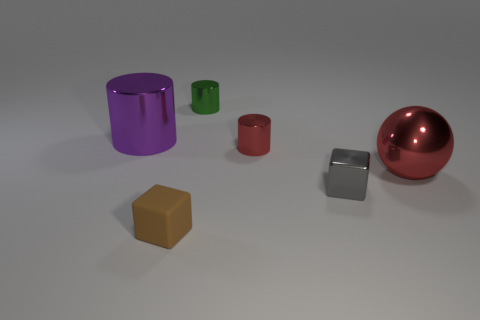Add 3 large red shiny things. How many objects exist? 9 Subtract all cubes. How many objects are left? 4 Subtract all small gray metal objects. Subtract all red metallic spheres. How many objects are left? 4 Add 5 tiny green things. How many tiny green things are left? 6 Add 5 large red objects. How many large red objects exist? 6 Subtract 0 gray spheres. How many objects are left? 6 